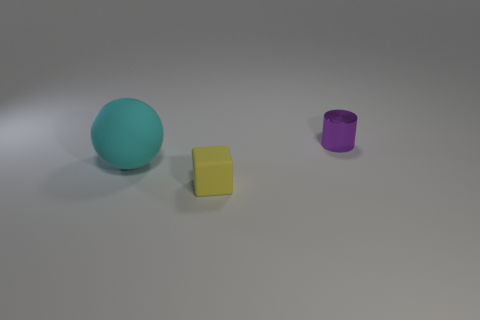Add 1 small yellow objects. How many objects exist? 4 Subtract all cylinders. How many objects are left? 2 Subtract all tiny brown things. Subtract all big cyan matte spheres. How many objects are left? 2 Add 2 big balls. How many big balls are left? 3 Add 3 matte balls. How many matte balls exist? 4 Subtract 1 purple cylinders. How many objects are left? 2 